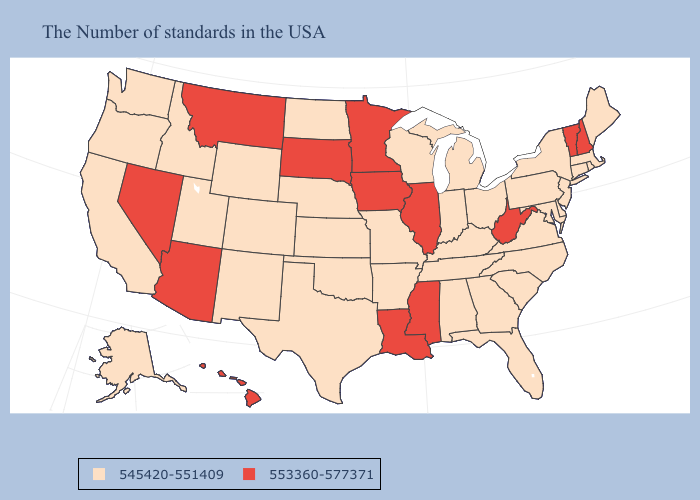What is the lowest value in states that border West Virginia?
Be succinct. 545420-551409. Name the states that have a value in the range 553360-577371?
Keep it brief. New Hampshire, Vermont, West Virginia, Illinois, Mississippi, Louisiana, Minnesota, Iowa, South Dakota, Montana, Arizona, Nevada, Hawaii. Name the states that have a value in the range 545420-551409?
Keep it brief. Maine, Massachusetts, Rhode Island, Connecticut, New York, New Jersey, Delaware, Maryland, Pennsylvania, Virginia, North Carolina, South Carolina, Ohio, Florida, Georgia, Michigan, Kentucky, Indiana, Alabama, Tennessee, Wisconsin, Missouri, Arkansas, Kansas, Nebraska, Oklahoma, Texas, North Dakota, Wyoming, Colorado, New Mexico, Utah, Idaho, California, Washington, Oregon, Alaska. What is the value of Montana?
Be succinct. 553360-577371. Name the states that have a value in the range 545420-551409?
Concise answer only. Maine, Massachusetts, Rhode Island, Connecticut, New York, New Jersey, Delaware, Maryland, Pennsylvania, Virginia, North Carolina, South Carolina, Ohio, Florida, Georgia, Michigan, Kentucky, Indiana, Alabama, Tennessee, Wisconsin, Missouri, Arkansas, Kansas, Nebraska, Oklahoma, Texas, North Dakota, Wyoming, Colorado, New Mexico, Utah, Idaho, California, Washington, Oregon, Alaska. Name the states that have a value in the range 545420-551409?
Write a very short answer. Maine, Massachusetts, Rhode Island, Connecticut, New York, New Jersey, Delaware, Maryland, Pennsylvania, Virginia, North Carolina, South Carolina, Ohio, Florida, Georgia, Michigan, Kentucky, Indiana, Alabama, Tennessee, Wisconsin, Missouri, Arkansas, Kansas, Nebraska, Oklahoma, Texas, North Dakota, Wyoming, Colorado, New Mexico, Utah, Idaho, California, Washington, Oregon, Alaska. Does the first symbol in the legend represent the smallest category?
Be succinct. Yes. What is the value of Texas?
Give a very brief answer. 545420-551409. Among the states that border Iowa , which have the lowest value?
Answer briefly. Wisconsin, Missouri, Nebraska. Name the states that have a value in the range 545420-551409?
Short answer required. Maine, Massachusetts, Rhode Island, Connecticut, New York, New Jersey, Delaware, Maryland, Pennsylvania, Virginia, North Carolina, South Carolina, Ohio, Florida, Georgia, Michigan, Kentucky, Indiana, Alabama, Tennessee, Wisconsin, Missouri, Arkansas, Kansas, Nebraska, Oklahoma, Texas, North Dakota, Wyoming, Colorado, New Mexico, Utah, Idaho, California, Washington, Oregon, Alaska. Name the states that have a value in the range 545420-551409?
Quick response, please. Maine, Massachusetts, Rhode Island, Connecticut, New York, New Jersey, Delaware, Maryland, Pennsylvania, Virginia, North Carolina, South Carolina, Ohio, Florida, Georgia, Michigan, Kentucky, Indiana, Alabama, Tennessee, Wisconsin, Missouri, Arkansas, Kansas, Nebraska, Oklahoma, Texas, North Dakota, Wyoming, Colorado, New Mexico, Utah, Idaho, California, Washington, Oregon, Alaska. Does New Hampshire have the highest value in the Northeast?
Be succinct. Yes. What is the value of Illinois?
Keep it brief. 553360-577371. 